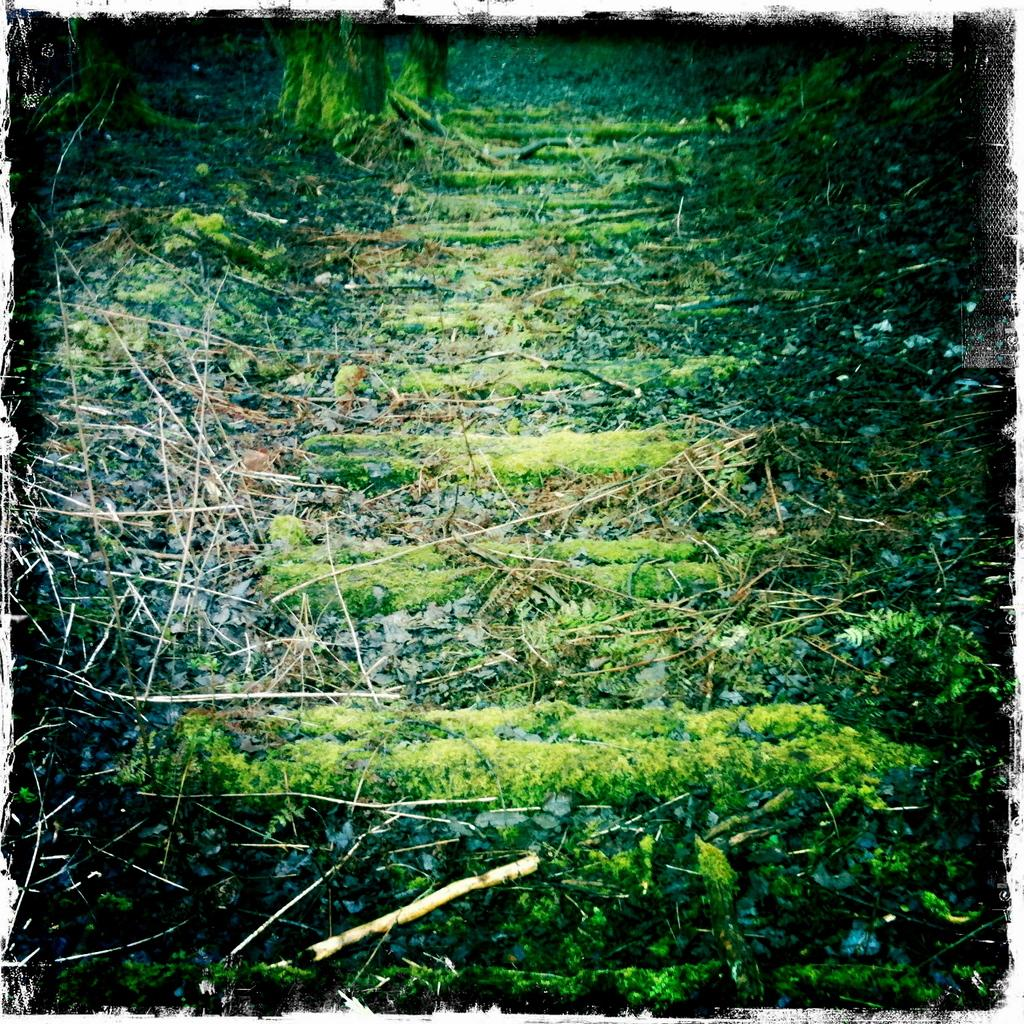What type of environment is depicted in the image? The image contains a significant amount of greenery, suggesting a natural or outdoor setting. Can you see any skateboards in the image? There is no mention of skateboards in the provided facts, and therefore we cannot determine if any are present in the image. 